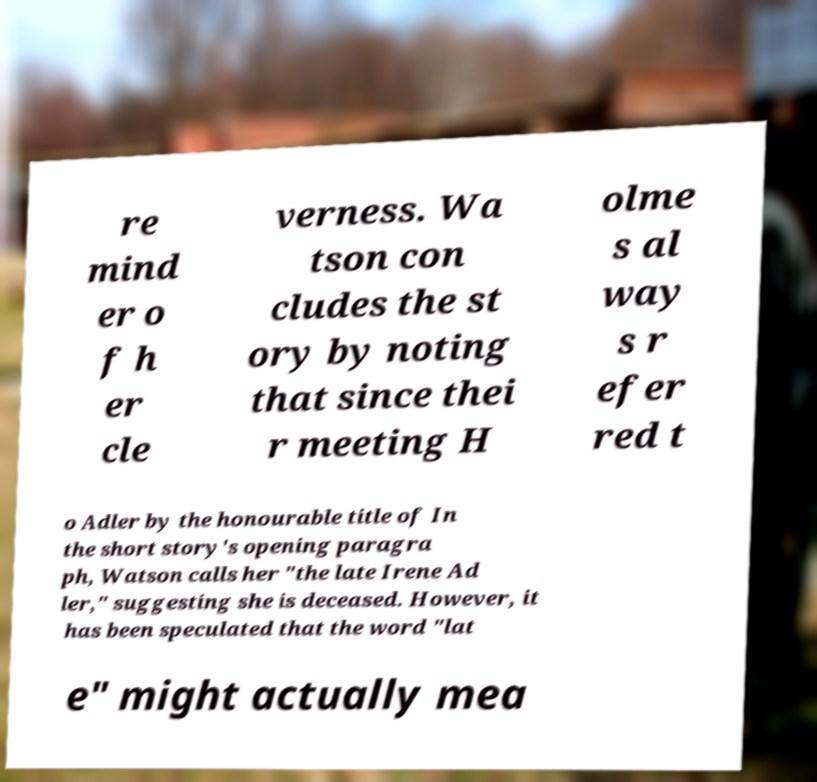What messages or text are displayed in this image? I need them in a readable, typed format. re mind er o f h er cle verness. Wa tson con cludes the st ory by noting that since thei r meeting H olme s al way s r efer red t o Adler by the honourable title of In the short story's opening paragra ph, Watson calls her "the late Irene Ad ler," suggesting she is deceased. However, it has been speculated that the word "lat e" might actually mea 